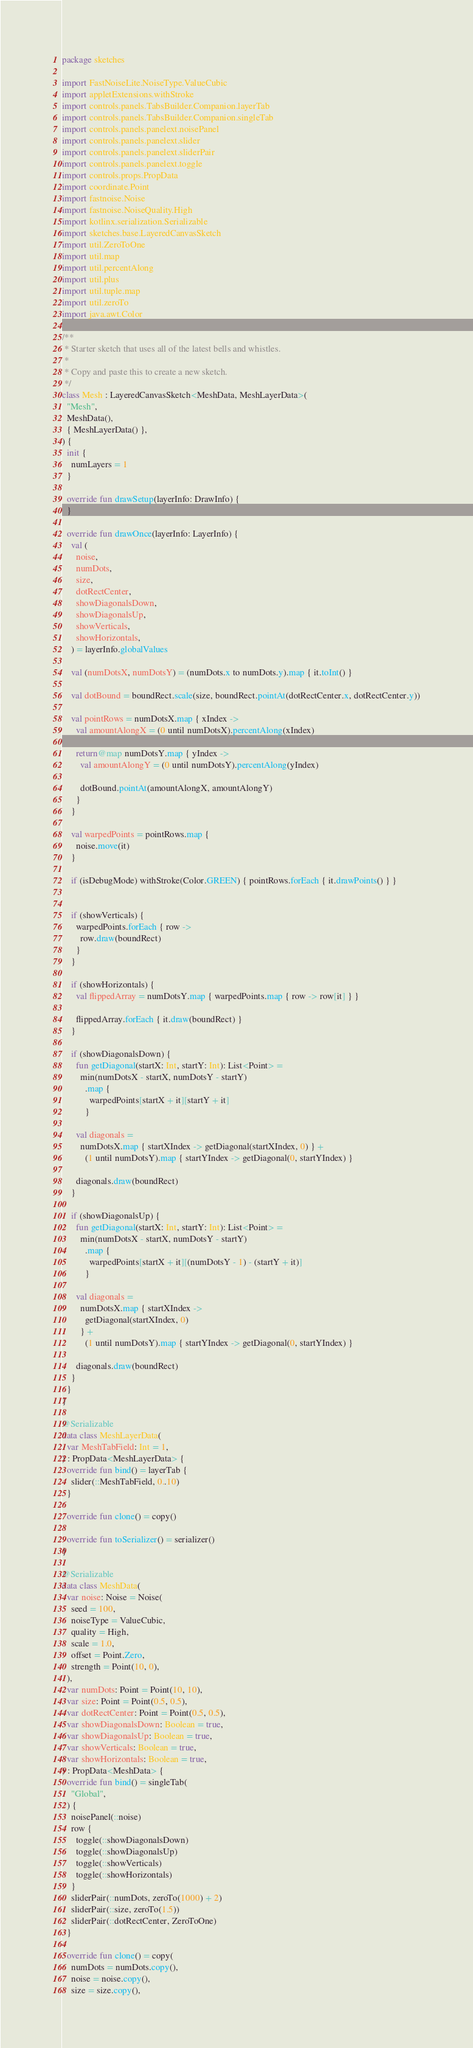Convert code to text. <code><loc_0><loc_0><loc_500><loc_500><_Kotlin_>package sketches

import FastNoiseLite.NoiseType.ValueCubic
import appletExtensions.withStroke
import controls.panels.TabsBuilder.Companion.layerTab
import controls.panels.TabsBuilder.Companion.singleTab
import controls.panels.panelext.noisePanel
import controls.panels.panelext.slider
import controls.panels.panelext.sliderPair
import controls.panels.panelext.toggle
import controls.props.PropData
import coordinate.Point
import fastnoise.Noise
import fastnoise.NoiseQuality.High
import kotlinx.serialization.Serializable
import sketches.base.LayeredCanvasSketch
import util.ZeroToOne
import util.map
import util.percentAlong
import util.plus
import util.tuple.map
import util.zeroTo
import java.awt.Color

/**
 * Starter sketch that uses all of the latest bells and whistles.
 *
 * Copy and paste this to create a new sketch.
 */
class Mesh : LayeredCanvasSketch<MeshData, MeshLayerData>(
  "Mesh",
  MeshData(),
  { MeshLayerData() },
) {
  init {
    numLayers = 1
  }

  override fun drawSetup(layerInfo: DrawInfo) {
  }

  override fun drawOnce(layerInfo: LayerInfo) {
    val (
      noise,
      numDots,
      size,
      dotRectCenter,
      showDiagonalsDown,
      showDiagonalsUp,
      showVerticals,
      showHorizontals,
    ) = layerInfo.globalValues

    val (numDotsX, numDotsY) = (numDots.x to numDots.y).map { it.toInt() }

    val dotBound = boundRect.scale(size, boundRect.pointAt(dotRectCenter.x, dotRectCenter.y))

    val pointRows = numDotsX.map { xIndex ->
      val amountAlongX = (0 until numDotsX).percentAlong(xIndex)

      return@map numDotsY.map { yIndex ->
        val amountAlongY = (0 until numDotsY).percentAlong(yIndex)

        dotBound.pointAt(amountAlongX, amountAlongY)
      }
    }

    val warpedPoints = pointRows.map {
      noise.move(it)
    }

    if (isDebugMode) withStroke(Color.GREEN) { pointRows.forEach { it.drawPoints() } }


    if (showVerticals) {
      warpedPoints.forEach { row ->
        row.draw(boundRect)
      }
    }

    if (showHorizontals) {
      val flippedArray = numDotsY.map { warpedPoints.map { row -> row[it] } }

      flippedArray.forEach { it.draw(boundRect) }
    }

    if (showDiagonalsDown) {
      fun getDiagonal(startX: Int, startY: Int): List<Point> =
        min(numDotsX - startX, numDotsY - startY)
          .map {
            warpedPoints[startX + it][startY + it]
          }

      val diagonals =
        numDotsX.map { startXIndex -> getDiagonal(startXIndex, 0) } +
          (1 until numDotsY).map { startYIndex -> getDiagonal(0, startYIndex) }

      diagonals.draw(boundRect)
    }

    if (showDiagonalsUp) {
      fun getDiagonal(startX: Int, startY: Int): List<Point> =
        min(numDotsX - startX, numDotsY - startY)
          .map {
            warpedPoints[startX + it][(numDotsY - 1) - (startY + it)]
          }

      val diagonals =
        numDotsX.map { startXIndex ->
          getDiagonal(startXIndex, 0)
        } +
          (1 until numDotsY).map { startYIndex -> getDiagonal(0, startYIndex) }

      diagonals.draw(boundRect)
    }
  }
}

@Serializable
data class MeshLayerData(
  var MeshTabField: Int = 1,
) : PropData<MeshLayerData> {
  override fun bind() = layerTab {
    slider(::MeshTabField, 0..10)
  }

  override fun clone() = copy()

  override fun toSerializer() = serializer()
}

@Serializable
data class MeshData(
  var noise: Noise = Noise(
    seed = 100,
    noiseType = ValueCubic,
    quality = High,
    scale = 1.0,
    offset = Point.Zero,
    strength = Point(10, 0),
  ),
  var numDots: Point = Point(10, 10),
  var size: Point = Point(0.5, 0.5),
  var dotRectCenter: Point = Point(0.5, 0.5),
  var showDiagonalsDown: Boolean = true,
  var showDiagonalsUp: Boolean = true,
  var showVerticals: Boolean = true,
  var showHorizontals: Boolean = true,
) : PropData<MeshData> {
  override fun bind() = singleTab(
    "Global",
  ) {
    noisePanel(::noise)
    row {
      toggle(::showDiagonalsDown)
      toggle(::showDiagonalsUp)
      toggle(::showVerticals)
      toggle(::showHorizontals)
    }
    sliderPair(::numDots, zeroTo(1000) + 2)
    sliderPair(::size, zeroTo(1.5))
    sliderPair(::dotRectCenter, ZeroToOne)
  }

  override fun clone() = copy(
    numDots = numDots.copy(),
    noise = noise.copy(),
    size = size.copy(),</code> 